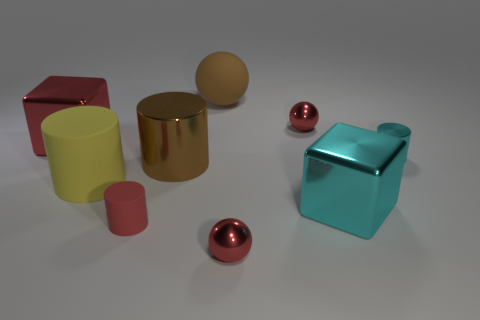The red cylinder has what size?
Provide a succinct answer. Small. Is the number of small metallic objects that are behind the yellow thing greater than the number of red cylinders?
Offer a terse response. Yes. Are there any other things that have the same material as the big yellow thing?
Your answer should be very brief. Yes. Is the color of the tiny shiny sphere that is behind the big brown metal object the same as the metal sphere that is in front of the tiny red rubber thing?
Your answer should be compact. Yes. What is the cube that is to the right of the small metal thing left of the red ball that is behind the red rubber thing made of?
Offer a terse response. Metal. Is the number of brown metal objects greater than the number of small red metallic things?
Offer a terse response. No. Is there anything else of the same color as the big rubber ball?
Your response must be concise. Yes. What size is the yellow cylinder that is the same material as the big brown sphere?
Give a very brief answer. Large. What is the big brown ball made of?
Keep it short and to the point. Rubber. What number of cyan metallic objects have the same size as the brown metal thing?
Provide a succinct answer. 1. 